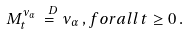<formula> <loc_0><loc_0><loc_500><loc_500>M _ { t } ^ { \nu _ { \alpha } } \stackrel { \ D } { = } \nu _ { \alpha } \, , f o r a l l \, t \geq 0 \, .</formula> 